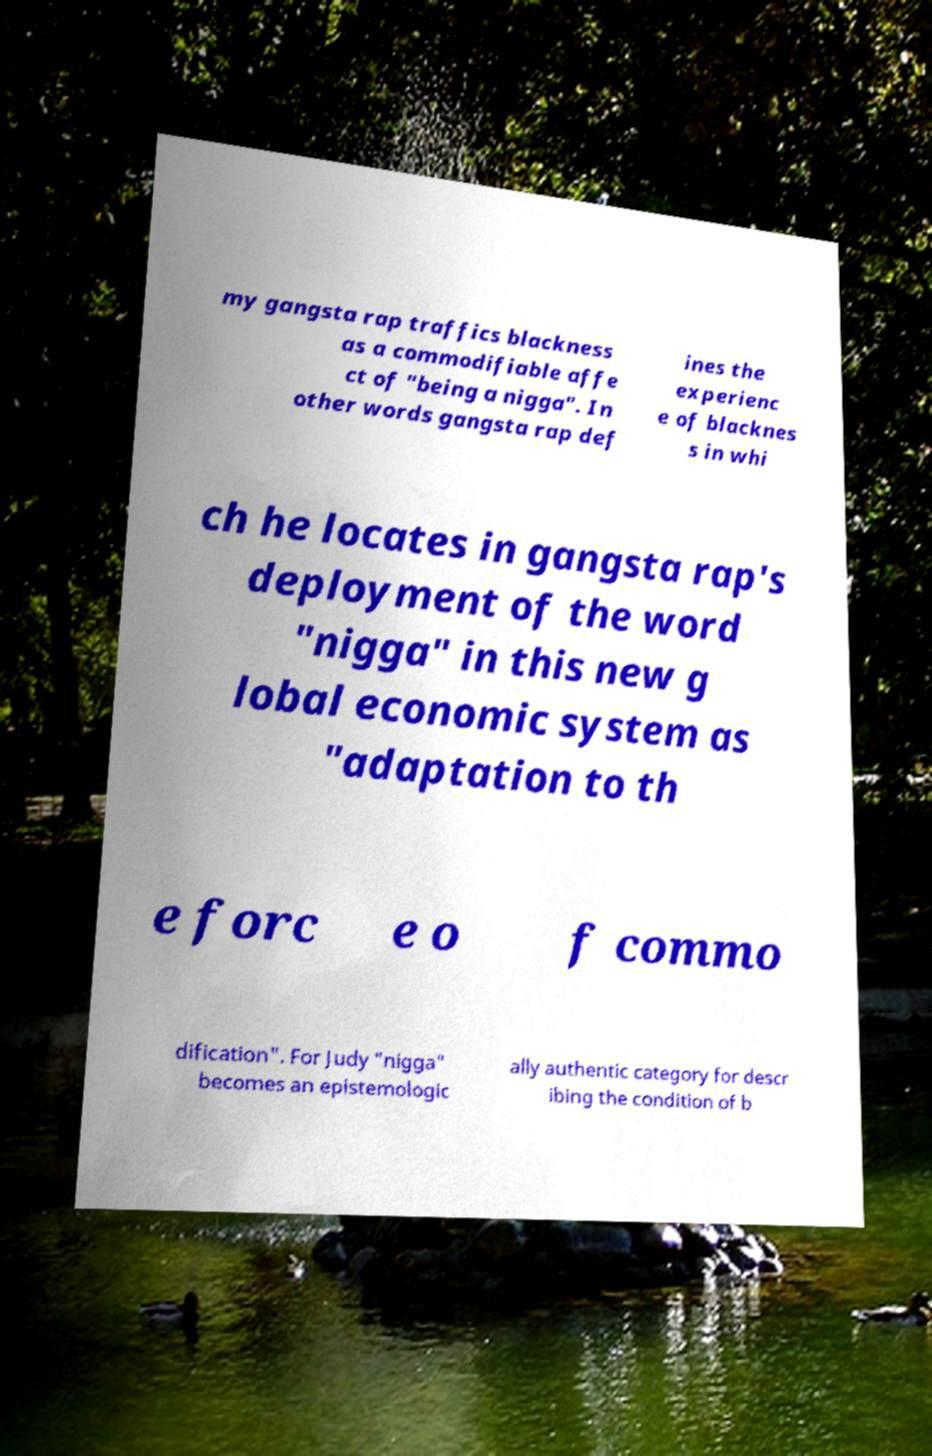Can you read and provide the text displayed in the image?This photo seems to have some interesting text. Can you extract and type it out for me? my gangsta rap traffics blackness as a commodifiable affe ct of "being a nigga". In other words gangsta rap def ines the experienc e of blacknes s in whi ch he locates in gangsta rap's deployment of the word "nigga" in this new g lobal economic system as "adaptation to th e forc e o f commo dification". For Judy "nigga" becomes an epistemologic ally authentic category for descr ibing the condition of b 